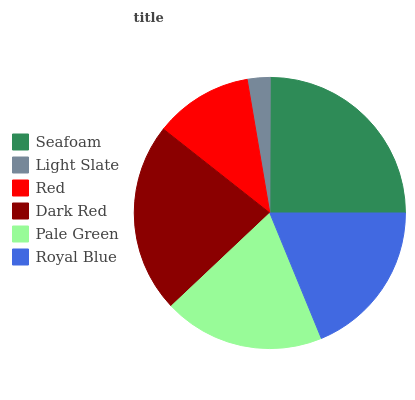Is Light Slate the minimum?
Answer yes or no. Yes. Is Seafoam the maximum?
Answer yes or no. Yes. Is Red the minimum?
Answer yes or no. No. Is Red the maximum?
Answer yes or no. No. Is Red greater than Light Slate?
Answer yes or no. Yes. Is Light Slate less than Red?
Answer yes or no. Yes. Is Light Slate greater than Red?
Answer yes or no. No. Is Red less than Light Slate?
Answer yes or no. No. Is Pale Green the high median?
Answer yes or no. Yes. Is Royal Blue the low median?
Answer yes or no. Yes. Is Red the high median?
Answer yes or no. No. Is Seafoam the low median?
Answer yes or no. No. 